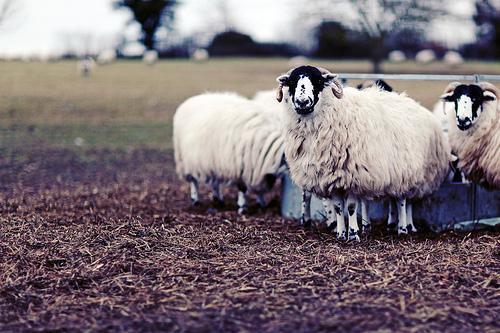How many elephants are pictured?
Give a very brief answer. 0. How many sheep are facing forward?
Give a very brief answer. 2. 